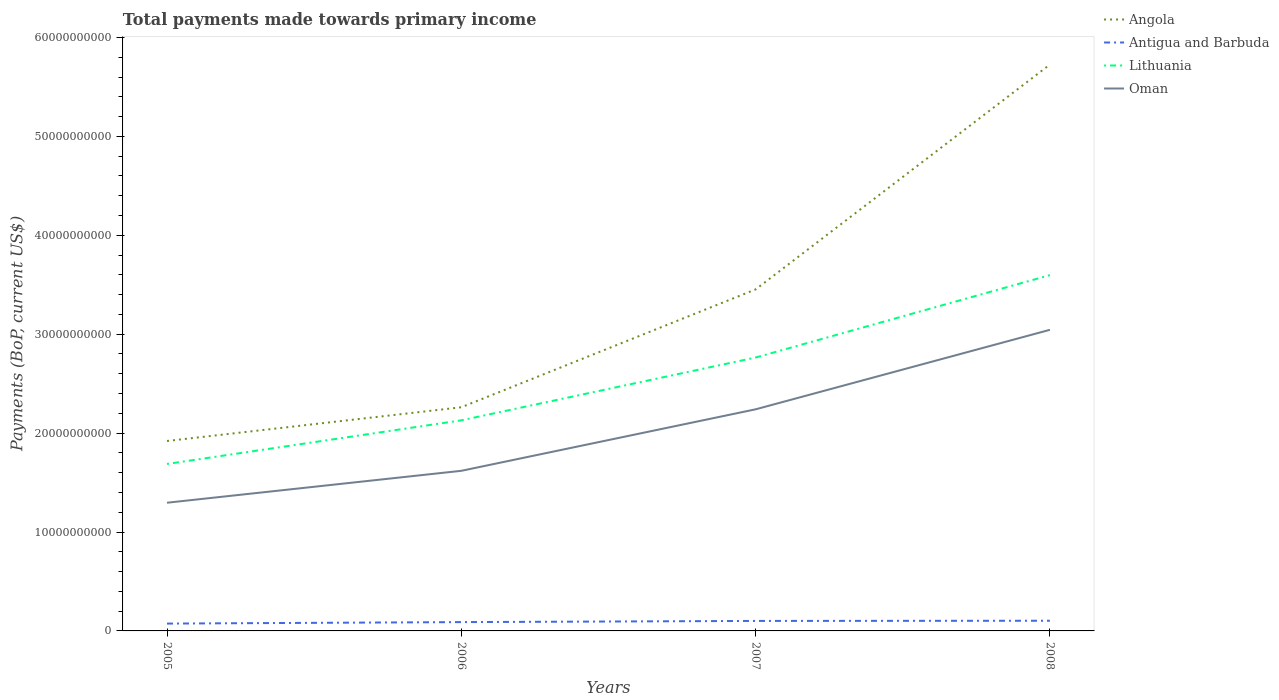How many different coloured lines are there?
Provide a short and direct response. 4. Does the line corresponding to Lithuania intersect with the line corresponding to Oman?
Ensure brevity in your answer.  No. Across all years, what is the maximum total payments made towards primary income in Oman?
Your answer should be compact. 1.30e+1. In which year was the total payments made towards primary income in Angola maximum?
Your answer should be compact. 2005. What is the total total payments made towards primary income in Angola in the graph?
Provide a short and direct response. -3.81e+1. What is the difference between the highest and the second highest total payments made towards primary income in Antigua and Barbuda?
Ensure brevity in your answer.  2.87e+08. How many lines are there?
Keep it short and to the point. 4. How many years are there in the graph?
Give a very brief answer. 4. What is the difference between two consecutive major ticks on the Y-axis?
Your answer should be very brief. 1.00e+1. Are the values on the major ticks of Y-axis written in scientific E-notation?
Keep it short and to the point. No. Does the graph contain any zero values?
Provide a short and direct response. No. Does the graph contain grids?
Provide a succinct answer. No. How many legend labels are there?
Offer a terse response. 4. How are the legend labels stacked?
Give a very brief answer. Vertical. What is the title of the graph?
Give a very brief answer. Total payments made towards primary income. Does "High income: OECD" appear as one of the legend labels in the graph?
Provide a succinct answer. No. What is the label or title of the Y-axis?
Ensure brevity in your answer.  Payments (BoP, current US$). What is the Payments (BoP, current US$) of Angola in 2005?
Make the answer very short. 1.92e+1. What is the Payments (BoP, current US$) of Antigua and Barbuda in 2005?
Make the answer very short. 7.43e+08. What is the Payments (BoP, current US$) of Lithuania in 2005?
Give a very brief answer. 1.69e+1. What is the Payments (BoP, current US$) in Oman in 2005?
Provide a succinct answer. 1.30e+1. What is the Payments (BoP, current US$) of Angola in 2006?
Keep it short and to the point. 2.26e+1. What is the Payments (BoP, current US$) in Antigua and Barbuda in 2006?
Make the answer very short. 8.92e+08. What is the Payments (BoP, current US$) of Lithuania in 2006?
Provide a short and direct response. 2.13e+1. What is the Payments (BoP, current US$) of Oman in 2006?
Give a very brief answer. 1.62e+1. What is the Payments (BoP, current US$) in Angola in 2007?
Your answer should be very brief. 3.45e+1. What is the Payments (BoP, current US$) in Antigua and Barbuda in 2007?
Give a very brief answer. 1.01e+09. What is the Payments (BoP, current US$) in Lithuania in 2007?
Provide a short and direct response. 2.76e+1. What is the Payments (BoP, current US$) in Oman in 2007?
Your answer should be compact. 2.24e+1. What is the Payments (BoP, current US$) of Angola in 2008?
Make the answer very short. 5.73e+1. What is the Payments (BoP, current US$) of Antigua and Barbuda in 2008?
Provide a short and direct response. 1.03e+09. What is the Payments (BoP, current US$) in Lithuania in 2008?
Your answer should be compact. 3.60e+1. What is the Payments (BoP, current US$) of Oman in 2008?
Keep it short and to the point. 3.04e+1. Across all years, what is the maximum Payments (BoP, current US$) of Angola?
Keep it short and to the point. 5.73e+1. Across all years, what is the maximum Payments (BoP, current US$) in Antigua and Barbuda?
Provide a succinct answer. 1.03e+09. Across all years, what is the maximum Payments (BoP, current US$) in Lithuania?
Your response must be concise. 3.60e+1. Across all years, what is the maximum Payments (BoP, current US$) of Oman?
Provide a short and direct response. 3.04e+1. Across all years, what is the minimum Payments (BoP, current US$) of Angola?
Your response must be concise. 1.92e+1. Across all years, what is the minimum Payments (BoP, current US$) in Antigua and Barbuda?
Provide a short and direct response. 7.43e+08. Across all years, what is the minimum Payments (BoP, current US$) of Lithuania?
Provide a succinct answer. 1.69e+1. Across all years, what is the minimum Payments (BoP, current US$) of Oman?
Ensure brevity in your answer.  1.30e+1. What is the total Payments (BoP, current US$) of Angola in the graph?
Give a very brief answer. 1.34e+11. What is the total Payments (BoP, current US$) in Antigua and Barbuda in the graph?
Your response must be concise. 3.67e+09. What is the total Payments (BoP, current US$) of Lithuania in the graph?
Ensure brevity in your answer.  1.02e+11. What is the total Payments (BoP, current US$) in Oman in the graph?
Keep it short and to the point. 8.20e+1. What is the difference between the Payments (BoP, current US$) of Angola in 2005 and that in 2006?
Provide a succinct answer. -3.41e+09. What is the difference between the Payments (BoP, current US$) in Antigua and Barbuda in 2005 and that in 2006?
Your answer should be very brief. -1.49e+08. What is the difference between the Payments (BoP, current US$) in Lithuania in 2005 and that in 2006?
Keep it short and to the point. -4.41e+09. What is the difference between the Payments (BoP, current US$) in Oman in 2005 and that in 2006?
Give a very brief answer. -3.23e+09. What is the difference between the Payments (BoP, current US$) in Angola in 2005 and that in 2007?
Provide a short and direct response. -1.53e+1. What is the difference between the Payments (BoP, current US$) of Antigua and Barbuda in 2005 and that in 2007?
Your answer should be compact. -2.68e+08. What is the difference between the Payments (BoP, current US$) of Lithuania in 2005 and that in 2007?
Provide a short and direct response. -1.08e+1. What is the difference between the Payments (BoP, current US$) of Oman in 2005 and that in 2007?
Offer a very short reply. -9.44e+09. What is the difference between the Payments (BoP, current US$) in Angola in 2005 and that in 2008?
Provide a succinct answer. -3.81e+1. What is the difference between the Payments (BoP, current US$) in Antigua and Barbuda in 2005 and that in 2008?
Give a very brief answer. -2.87e+08. What is the difference between the Payments (BoP, current US$) in Lithuania in 2005 and that in 2008?
Make the answer very short. -1.91e+1. What is the difference between the Payments (BoP, current US$) in Oman in 2005 and that in 2008?
Your answer should be very brief. -1.75e+1. What is the difference between the Payments (BoP, current US$) in Angola in 2006 and that in 2007?
Ensure brevity in your answer.  -1.19e+1. What is the difference between the Payments (BoP, current US$) of Antigua and Barbuda in 2006 and that in 2007?
Offer a very short reply. -1.19e+08. What is the difference between the Payments (BoP, current US$) of Lithuania in 2006 and that in 2007?
Your answer should be very brief. -6.35e+09. What is the difference between the Payments (BoP, current US$) in Oman in 2006 and that in 2007?
Keep it short and to the point. -6.22e+09. What is the difference between the Payments (BoP, current US$) of Angola in 2006 and that in 2008?
Offer a very short reply. -3.46e+1. What is the difference between the Payments (BoP, current US$) in Antigua and Barbuda in 2006 and that in 2008?
Provide a succinct answer. -1.38e+08. What is the difference between the Payments (BoP, current US$) of Lithuania in 2006 and that in 2008?
Your answer should be very brief. -1.47e+1. What is the difference between the Payments (BoP, current US$) of Oman in 2006 and that in 2008?
Keep it short and to the point. -1.43e+1. What is the difference between the Payments (BoP, current US$) of Angola in 2007 and that in 2008?
Provide a succinct answer. -2.27e+1. What is the difference between the Payments (BoP, current US$) of Antigua and Barbuda in 2007 and that in 2008?
Provide a short and direct response. -1.86e+07. What is the difference between the Payments (BoP, current US$) in Lithuania in 2007 and that in 2008?
Offer a terse response. -8.33e+09. What is the difference between the Payments (BoP, current US$) in Oman in 2007 and that in 2008?
Offer a terse response. -8.04e+09. What is the difference between the Payments (BoP, current US$) in Angola in 2005 and the Payments (BoP, current US$) in Antigua and Barbuda in 2006?
Your response must be concise. 1.83e+1. What is the difference between the Payments (BoP, current US$) in Angola in 2005 and the Payments (BoP, current US$) in Lithuania in 2006?
Give a very brief answer. -2.09e+09. What is the difference between the Payments (BoP, current US$) in Angola in 2005 and the Payments (BoP, current US$) in Oman in 2006?
Your answer should be compact. 3.01e+09. What is the difference between the Payments (BoP, current US$) in Antigua and Barbuda in 2005 and the Payments (BoP, current US$) in Lithuania in 2006?
Ensure brevity in your answer.  -2.05e+1. What is the difference between the Payments (BoP, current US$) of Antigua and Barbuda in 2005 and the Payments (BoP, current US$) of Oman in 2006?
Make the answer very short. -1.54e+1. What is the difference between the Payments (BoP, current US$) of Lithuania in 2005 and the Payments (BoP, current US$) of Oman in 2006?
Offer a terse response. 6.93e+08. What is the difference between the Payments (BoP, current US$) in Angola in 2005 and the Payments (BoP, current US$) in Antigua and Barbuda in 2007?
Give a very brief answer. 1.82e+1. What is the difference between the Payments (BoP, current US$) in Angola in 2005 and the Payments (BoP, current US$) in Lithuania in 2007?
Offer a terse response. -8.44e+09. What is the difference between the Payments (BoP, current US$) of Angola in 2005 and the Payments (BoP, current US$) of Oman in 2007?
Offer a terse response. -3.20e+09. What is the difference between the Payments (BoP, current US$) of Antigua and Barbuda in 2005 and the Payments (BoP, current US$) of Lithuania in 2007?
Keep it short and to the point. -2.69e+1. What is the difference between the Payments (BoP, current US$) in Antigua and Barbuda in 2005 and the Payments (BoP, current US$) in Oman in 2007?
Ensure brevity in your answer.  -2.17e+1. What is the difference between the Payments (BoP, current US$) in Lithuania in 2005 and the Payments (BoP, current US$) in Oman in 2007?
Offer a very short reply. -5.52e+09. What is the difference between the Payments (BoP, current US$) in Angola in 2005 and the Payments (BoP, current US$) in Antigua and Barbuda in 2008?
Ensure brevity in your answer.  1.82e+1. What is the difference between the Payments (BoP, current US$) of Angola in 2005 and the Payments (BoP, current US$) of Lithuania in 2008?
Your answer should be very brief. -1.68e+1. What is the difference between the Payments (BoP, current US$) of Angola in 2005 and the Payments (BoP, current US$) of Oman in 2008?
Your answer should be very brief. -1.12e+1. What is the difference between the Payments (BoP, current US$) in Antigua and Barbuda in 2005 and the Payments (BoP, current US$) in Lithuania in 2008?
Ensure brevity in your answer.  -3.52e+1. What is the difference between the Payments (BoP, current US$) of Antigua and Barbuda in 2005 and the Payments (BoP, current US$) of Oman in 2008?
Offer a very short reply. -2.97e+1. What is the difference between the Payments (BoP, current US$) of Lithuania in 2005 and the Payments (BoP, current US$) of Oman in 2008?
Provide a short and direct response. -1.36e+1. What is the difference between the Payments (BoP, current US$) in Angola in 2006 and the Payments (BoP, current US$) in Antigua and Barbuda in 2007?
Make the answer very short. 2.16e+1. What is the difference between the Payments (BoP, current US$) of Angola in 2006 and the Payments (BoP, current US$) of Lithuania in 2007?
Provide a succinct answer. -5.03e+09. What is the difference between the Payments (BoP, current US$) of Angola in 2006 and the Payments (BoP, current US$) of Oman in 2007?
Offer a very short reply. 2.08e+08. What is the difference between the Payments (BoP, current US$) in Antigua and Barbuda in 2006 and the Payments (BoP, current US$) in Lithuania in 2007?
Ensure brevity in your answer.  -2.67e+1. What is the difference between the Payments (BoP, current US$) of Antigua and Barbuda in 2006 and the Payments (BoP, current US$) of Oman in 2007?
Provide a short and direct response. -2.15e+1. What is the difference between the Payments (BoP, current US$) of Lithuania in 2006 and the Payments (BoP, current US$) of Oman in 2007?
Offer a very short reply. -1.11e+09. What is the difference between the Payments (BoP, current US$) in Angola in 2006 and the Payments (BoP, current US$) in Antigua and Barbuda in 2008?
Provide a short and direct response. 2.16e+1. What is the difference between the Payments (BoP, current US$) in Angola in 2006 and the Payments (BoP, current US$) in Lithuania in 2008?
Offer a very short reply. -1.34e+1. What is the difference between the Payments (BoP, current US$) of Angola in 2006 and the Payments (BoP, current US$) of Oman in 2008?
Keep it short and to the point. -7.83e+09. What is the difference between the Payments (BoP, current US$) of Antigua and Barbuda in 2006 and the Payments (BoP, current US$) of Lithuania in 2008?
Your response must be concise. -3.51e+1. What is the difference between the Payments (BoP, current US$) in Antigua and Barbuda in 2006 and the Payments (BoP, current US$) in Oman in 2008?
Provide a succinct answer. -2.96e+1. What is the difference between the Payments (BoP, current US$) in Lithuania in 2006 and the Payments (BoP, current US$) in Oman in 2008?
Keep it short and to the point. -9.15e+09. What is the difference between the Payments (BoP, current US$) in Angola in 2007 and the Payments (BoP, current US$) in Antigua and Barbuda in 2008?
Make the answer very short. 3.35e+1. What is the difference between the Payments (BoP, current US$) of Angola in 2007 and the Payments (BoP, current US$) of Lithuania in 2008?
Offer a very short reply. -1.44e+09. What is the difference between the Payments (BoP, current US$) in Angola in 2007 and the Payments (BoP, current US$) in Oman in 2008?
Ensure brevity in your answer.  4.08e+09. What is the difference between the Payments (BoP, current US$) in Antigua and Barbuda in 2007 and the Payments (BoP, current US$) in Lithuania in 2008?
Make the answer very short. -3.50e+1. What is the difference between the Payments (BoP, current US$) of Antigua and Barbuda in 2007 and the Payments (BoP, current US$) of Oman in 2008?
Offer a terse response. -2.94e+1. What is the difference between the Payments (BoP, current US$) in Lithuania in 2007 and the Payments (BoP, current US$) in Oman in 2008?
Your answer should be compact. -2.80e+09. What is the average Payments (BoP, current US$) of Angola per year?
Offer a terse response. 3.34e+1. What is the average Payments (BoP, current US$) of Antigua and Barbuda per year?
Provide a succinct answer. 9.19e+08. What is the average Payments (BoP, current US$) in Lithuania per year?
Provide a short and direct response. 2.54e+1. What is the average Payments (BoP, current US$) in Oman per year?
Your response must be concise. 2.05e+1. In the year 2005, what is the difference between the Payments (BoP, current US$) of Angola and Payments (BoP, current US$) of Antigua and Barbuda?
Give a very brief answer. 1.85e+1. In the year 2005, what is the difference between the Payments (BoP, current US$) of Angola and Payments (BoP, current US$) of Lithuania?
Your answer should be compact. 2.32e+09. In the year 2005, what is the difference between the Payments (BoP, current US$) of Angola and Payments (BoP, current US$) of Oman?
Provide a succinct answer. 6.24e+09. In the year 2005, what is the difference between the Payments (BoP, current US$) in Antigua and Barbuda and Payments (BoP, current US$) in Lithuania?
Give a very brief answer. -1.61e+1. In the year 2005, what is the difference between the Payments (BoP, current US$) in Antigua and Barbuda and Payments (BoP, current US$) in Oman?
Your answer should be very brief. -1.22e+1. In the year 2005, what is the difference between the Payments (BoP, current US$) of Lithuania and Payments (BoP, current US$) of Oman?
Offer a very short reply. 3.92e+09. In the year 2006, what is the difference between the Payments (BoP, current US$) of Angola and Payments (BoP, current US$) of Antigua and Barbuda?
Your answer should be compact. 2.17e+1. In the year 2006, what is the difference between the Payments (BoP, current US$) of Angola and Payments (BoP, current US$) of Lithuania?
Your response must be concise. 1.32e+09. In the year 2006, what is the difference between the Payments (BoP, current US$) of Angola and Payments (BoP, current US$) of Oman?
Give a very brief answer. 6.42e+09. In the year 2006, what is the difference between the Payments (BoP, current US$) of Antigua and Barbuda and Payments (BoP, current US$) of Lithuania?
Provide a short and direct response. -2.04e+1. In the year 2006, what is the difference between the Payments (BoP, current US$) of Antigua and Barbuda and Payments (BoP, current US$) of Oman?
Offer a very short reply. -1.53e+1. In the year 2006, what is the difference between the Payments (BoP, current US$) in Lithuania and Payments (BoP, current US$) in Oman?
Give a very brief answer. 5.10e+09. In the year 2007, what is the difference between the Payments (BoP, current US$) in Angola and Payments (BoP, current US$) in Antigua and Barbuda?
Provide a succinct answer. 3.35e+1. In the year 2007, what is the difference between the Payments (BoP, current US$) of Angola and Payments (BoP, current US$) of Lithuania?
Make the answer very short. 6.89e+09. In the year 2007, what is the difference between the Payments (BoP, current US$) of Angola and Payments (BoP, current US$) of Oman?
Your answer should be compact. 1.21e+1. In the year 2007, what is the difference between the Payments (BoP, current US$) of Antigua and Barbuda and Payments (BoP, current US$) of Lithuania?
Offer a terse response. -2.66e+1. In the year 2007, what is the difference between the Payments (BoP, current US$) of Antigua and Barbuda and Payments (BoP, current US$) of Oman?
Offer a very short reply. -2.14e+1. In the year 2007, what is the difference between the Payments (BoP, current US$) in Lithuania and Payments (BoP, current US$) in Oman?
Offer a terse response. 5.24e+09. In the year 2008, what is the difference between the Payments (BoP, current US$) in Angola and Payments (BoP, current US$) in Antigua and Barbuda?
Offer a very short reply. 5.62e+1. In the year 2008, what is the difference between the Payments (BoP, current US$) of Angola and Payments (BoP, current US$) of Lithuania?
Ensure brevity in your answer.  2.13e+1. In the year 2008, what is the difference between the Payments (BoP, current US$) in Angola and Payments (BoP, current US$) in Oman?
Make the answer very short. 2.68e+1. In the year 2008, what is the difference between the Payments (BoP, current US$) in Antigua and Barbuda and Payments (BoP, current US$) in Lithuania?
Give a very brief answer. -3.49e+1. In the year 2008, what is the difference between the Payments (BoP, current US$) in Antigua and Barbuda and Payments (BoP, current US$) in Oman?
Ensure brevity in your answer.  -2.94e+1. In the year 2008, what is the difference between the Payments (BoP, current US$) in Lithuania and Payments (BoP, current US$) in Oman?
Offer a very short reply. 5.53e+09. What is the ratio of the Payments (BoP, current US$) in Angola in 2005 to that in 2006?
Make the answer very short. 0.85. What is the ratio of the Payments (BoP, current US$) in Antigua and Barbuda in 2005 to that in 2006?
Give a very brief answer. 0.83. What is the ratio of the Payments (BoP, current US$) in Lithuania in 2005 to that in 2006?
Your answer should be compact. 0.79. What is the ratio of the Payments (BoP, current US$) in Oman in 2005 to that in 2006?
Your answer should be compact. 0.8. What is the ratio of the Payments (BoP, current US$) of Angola in 2005 to that in 2007?
Offer a very short reply. 0.56. What is the ratio of the Payments (BoP, current US$) in Antigua and Barbuda in 2005 to that in 2007?
Offer a terse response. 0.73. What is the ratio of the Payments (BoP, current US$) in Lithuania in 2005 to that in 2007?
Offer a terse response. 0.61. What is the ratio of the Payments (BoP, current US$) in Oman in 2005 to that in 2007?
Provide a succinct answer. 0.58. What is the ratio of the Payments (BoP, current US$) in Angola in 2005 to that in 2008?
Provide a short and direct response. 0.34. What is the ratio of the Payments (BoP, current US$) of Antigua and Barbuda in 2005 to that in 2008?
Provide a short and direct response. 0.72. What is the ratio of the Payments (BoP, current US$) in Lithuania in 2005 to that in 2008?
Offer a very short reply. 0.47. What is the ratio of the Payments (BoP, current US$) of Oman in 2005 to that in 2008?
Offer a terse response. 0.43. What is the ratio of the Payments (BoP, current US$) in Angola in 2006 to that in 2007?
Ensure brevity in your answer.  0.65. What is the ratio of the Payments (BoP, current US$) in Antigua and Barbuda in 2006 to that in 2007?
Make the answer very short. 0.88. What is the ratio of the Payments (BoP, current US$) in Lithuania in 2006 to that in 2007?
Keep it short and to the point. 0.77. What is the ratio of the Payments (BoP, current US$) in Oman in 2006 to that in 2007?
Keep it short and to the point. 0.72. What is the ratio of the Payments (BoP, current US$) in Angola in 2006 to that in 2008?
Provide a succinct answer. 0.39. What is the ratio of the Payments (BoP, current US$) in Antigua and Barbuda in 2006 to that in 2008?
Make the answer very short. 0.87. What is the ratio of the Payments (BoP, current US$) of Lithuania in 2006 to that in 2008?
Keep it short and to the point. 0.59. What is the ratio of the Payments (BoP, current US$) of Oman in 2006 to that in 2008?
Offer a very short reply. 0.53. What is the ratio of the Payments (BoP, current US$) in Angola in 2007 to that in 2008?
Keep it short and to the point. 0.6. What is the ratio of the Payments (BoP, current US$) in Antigua and Barbuda in 2007 to that in 2008?
Ensure brevity in your answer.  0.98. What is the ratio of the Payments (BoP, current US$) in Lithuania in 2007 to that in 2008?
Your answer should be very brief. 0.77. What is the ratio of the Payments (BoP, current US$) of Oman in 2007 to that in 2008?
Your answer should be very brief. 0.74. What is the difference between the highest and the second highest Payments (BoP, current US$) in Angola?
Provide a short and direct response. 2.27e+1. What is the difference between the highest and the second highest Payments (BoP, current US$) in Antigua and Barbuda?
Your response must be concise. 1.86e+07. What is the difference between the highest and the second highest Payments (BoP, current US$) of Lithuania?
Your answer should be compact. 8.33e+09. What is the difference between the highest and the second highest Payments (BoP, current US$) in Oman?
Ensure brevity in your answer.  8.04e+09. What is the difference between the highest and the lowest Payments (BoP, current US$) in Angola?
Offer a very short reply. 3.81e+1. What is the difference between the highest and the lowest Payments (BoP, current US$) of Antigua and Barbuda?
Provide a short and direct response. 2.87e+08. What is the difference between the highest and the lowest Payments (BoP, current US$) in Lithuania?
Make the answer very short. 1.91e+1. What is the difference between the highest and the lowest Payments (BoP, current US$) of Oman?
Provide a short and direct response. 1.75e+1. 